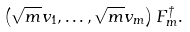Convert formula to latex. <formula><loc_0><loc_0><loc_500><loc_500>\left ( \sqrt { m } v _ { 1 } , \dots , \sqrt { m } v _ { m } \right ) F _ { m } ^ { \dagger } .</formula> 